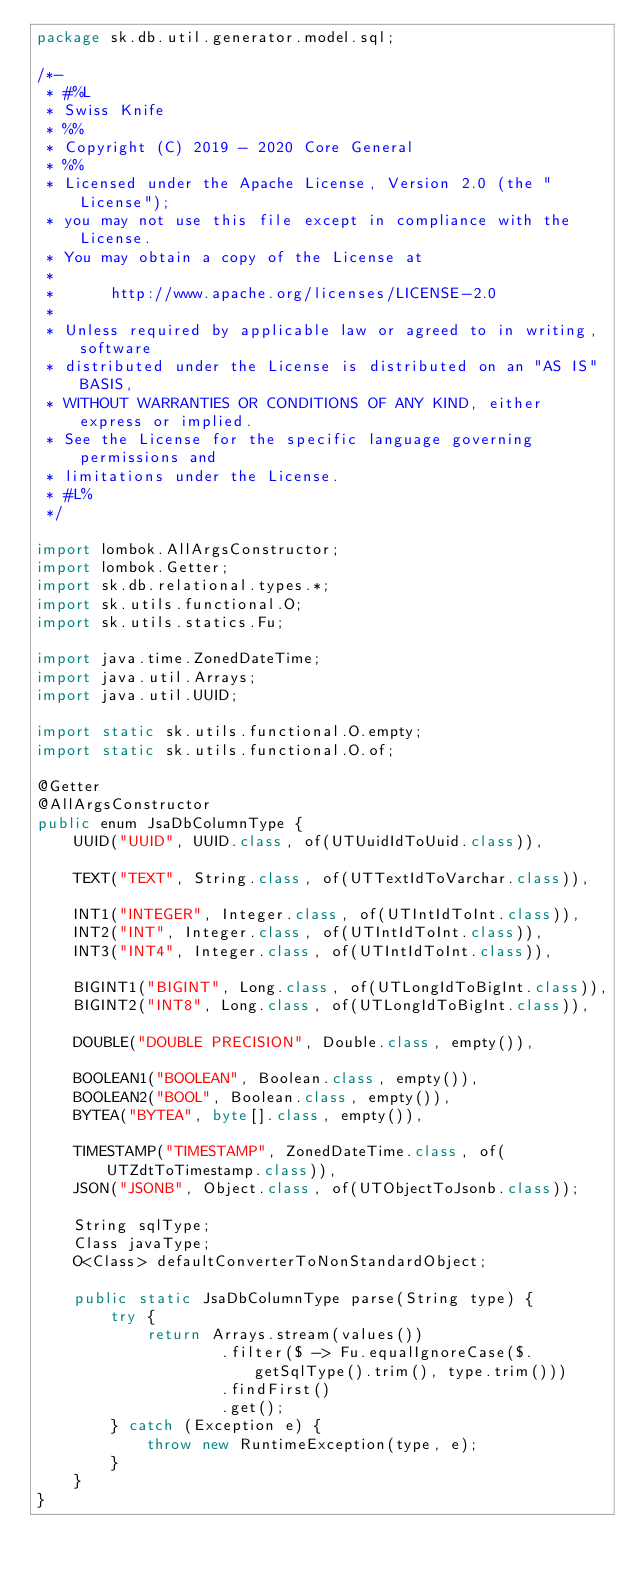<code> <loc_0><loc_0><loc_500><loc_500><_Java_>package sk.db.util.generator.model.sql;

/*-
 * #%L
 * Swiss Knife
 * %%
 * Copyright (C) 2019 - 2020 Core General
 * %%
 * Licensed under the Apache License, Version 2.0 (the "License");
 * you may not use this file except in compliance with the License.
 * You may obtain a copy of the License at
 *
 *      http://www.apache.org/licenses/LICENSE-2.0
 *
 * Unless required by applicable law or agreed to in writing, software
 * distributed under the License is distributed on an "AS IS" BASIS,
 * WITHOUT WARRANTIES OR CONDITIONS OF ANY KIND, either express or implied.
 * See the License for the specific language governing permissions and
 * limitations under the License.
 * #L%
 */

import lombok.AllArgsConstructor;
import lombok.Getter;
import sk.db.relational.types.*;
import sk.utils.functional.O;
import sk.utils.statics.Fu;

import java.time.ZonedDateTime;
import java.util.Arrays;
import java.util.UUID;

import static sk.utils.functional.O.empty;
import static sk.utils.functional.O.of;

@Getter
@AllArgsConstructor
public enum JsaDbColumnType {
    UUID("UUID", UUID.class, of(UTUuidIdToUuid.class)),

    TEXT("TEXT", String.class, of(UTTextIdToVarchar.class)),

    INT1("INTEGER", Integer.class, of(UTIntIdToInt.class)),
    INT2("INT", Integer.class, of(UTIntIdToInt.class)),
    INT3("INT4", Integer.class, of(UTIntIdToInt.class)),

    BIGINT1("BIGINT", Long.class, of(UTLongIdToBigInt.class)),
    BIGINT2("INT8", Long.class, of(UTLongIdToBigInt.class)),

    DOUBLE("DOUBLE PRECISION", Double.class, empty()),

    BOOLEAN1("BOOLEAN", Boolean.class, empty()),
    BOOLEAN2("BOOL", Boolean.class, empty()),
    BYTEA("BYTEA", byte[].class, empty()),

    TIMESTAMP("TIMESTAMP", ZonedDateTime.class, of(UTZdtToTimestamp.class)),
    JSON("JSONB", Object.class, of(UTObjectToJsonb.class));

    String sqlType;
    Class javaType;
    O<Class> defaultConverterToNonStandardObject;

    public static JsaDbColumnType parse(String type) {
        try {
            return Arrays.stream(values())
                    .filter($ -> Fu.equalIgnoreCase($.getSqlType().trim(), type.trim()))
                    .findFirst()
                    .get();
        } catch (Exception e) {
            throw new RuntimeException(type, e);
        }
    }
}
</code> 